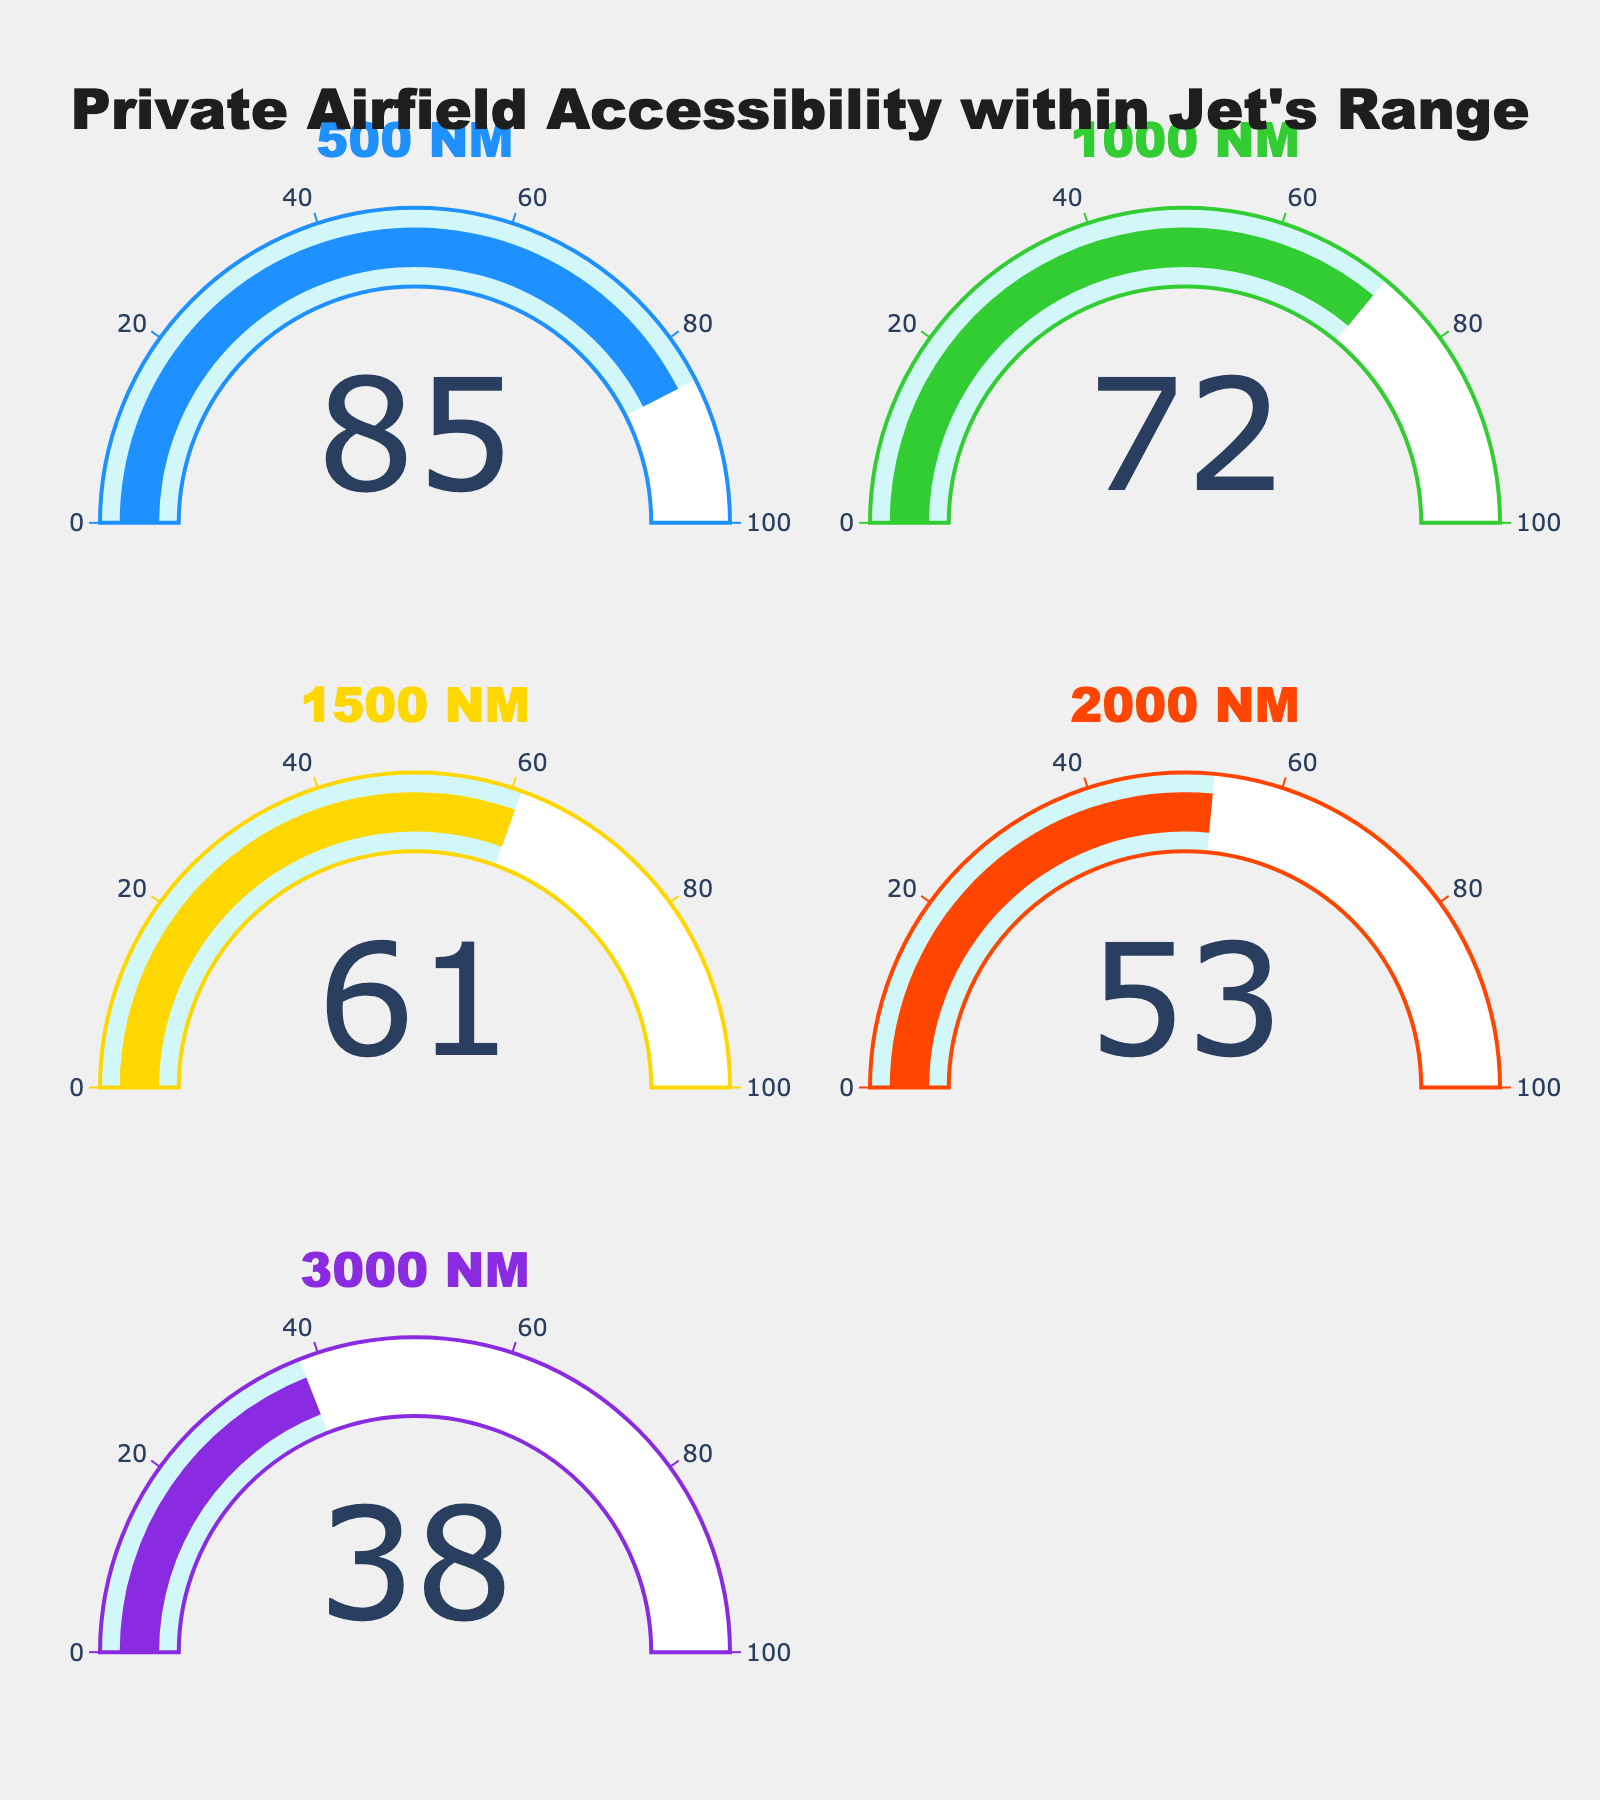What's the title of the figure? The title is located at the top of the figure, and it describes the content or main idea of the chart. In this case, the title is "Private Airfield Accessibility within Jet's Range".
Answer: Private Airfield Accessibility within Jet's Range What's the accessibility percentage for a range of 1500 NM? The value displayed in the gauge for the 1500 NM range is the accessibility percentage. According to the figure, it's 61.
Answer: 61 Which range has the highest airfield accessibility percentage? By looking at all the gauges, we can compare the values and see which one is the highest. The gauge for 500 NM has the highest value, which is 85.
Answer: 500 NM How much greater is the accessibility at 500 NM compared to 2000 NM? We need to find the difference in accessibility percentages between the 500 NM and 2000 NM ranges. The values are 85 for 500 NM and 53 for 2000 NM. Subtract 53 from 85 to get the answer.
Answer: 32 What's the average accessibility percentage for ranges 1000 NM, 1500 NM, and 2000 NM? To find the average accessibility for these ranges, sum the accessibility percentages for 1000 NM (72), 1500 NM (61), and 2000 NM (53), then divide by 3. The calculation is (72 + 61 + 53) / 3.
Answer: 62 Among the displayed ranges, which one has the lowest airfield accessibility percentage? We need to find the least value among all the gauges. The smallest value is 38 for the 3000 NM range.
Answer: 3000 NM Is the accessibility percentage for 1000 NM higher or lower than that for 3000 NM? We compare the values of the gauges for 1000 NM and 3000 NM. The value for 1000 NM is 72, and for 3000 NM, it's 38. Therefore, 72 is higher than 38.
Answer: Higher How many gauges are there, and in what layout are they displayed? Counting the gauges, we can see there are 5. They are arranged in a 3x2 grid, with the last space being empty.
Answer: 5 gauges, 3x2 grid What's the median accessibility percentage value among the given ranges? To find the median, list the accessibility values in ascending order: 38, 53, 61, 72, 85. The median value is the middle one, which is 61.
Answer: 61 